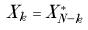<formula> <loc_0><loc_0><loc_500><loc_500>X _ { k } = X _ { N - k } ^ { * }</formula> 